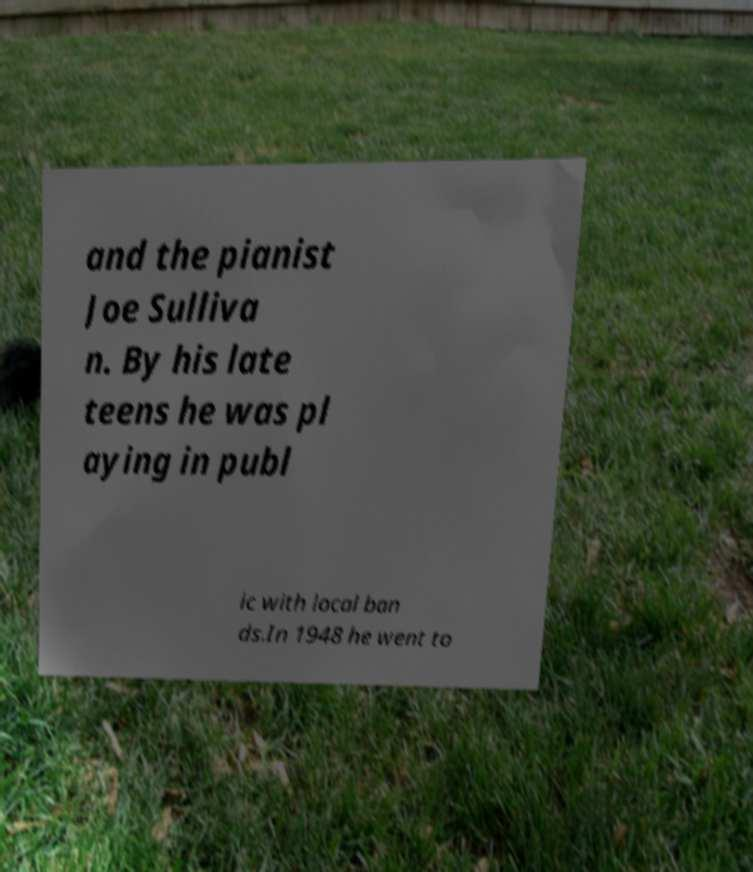Could you assist in decoding the text presented in this image and type it out clearly? and the pianist Joe Sulliva n. By his late teens he was pl aying in publ ic with local ban ds.In 1948 he went to 